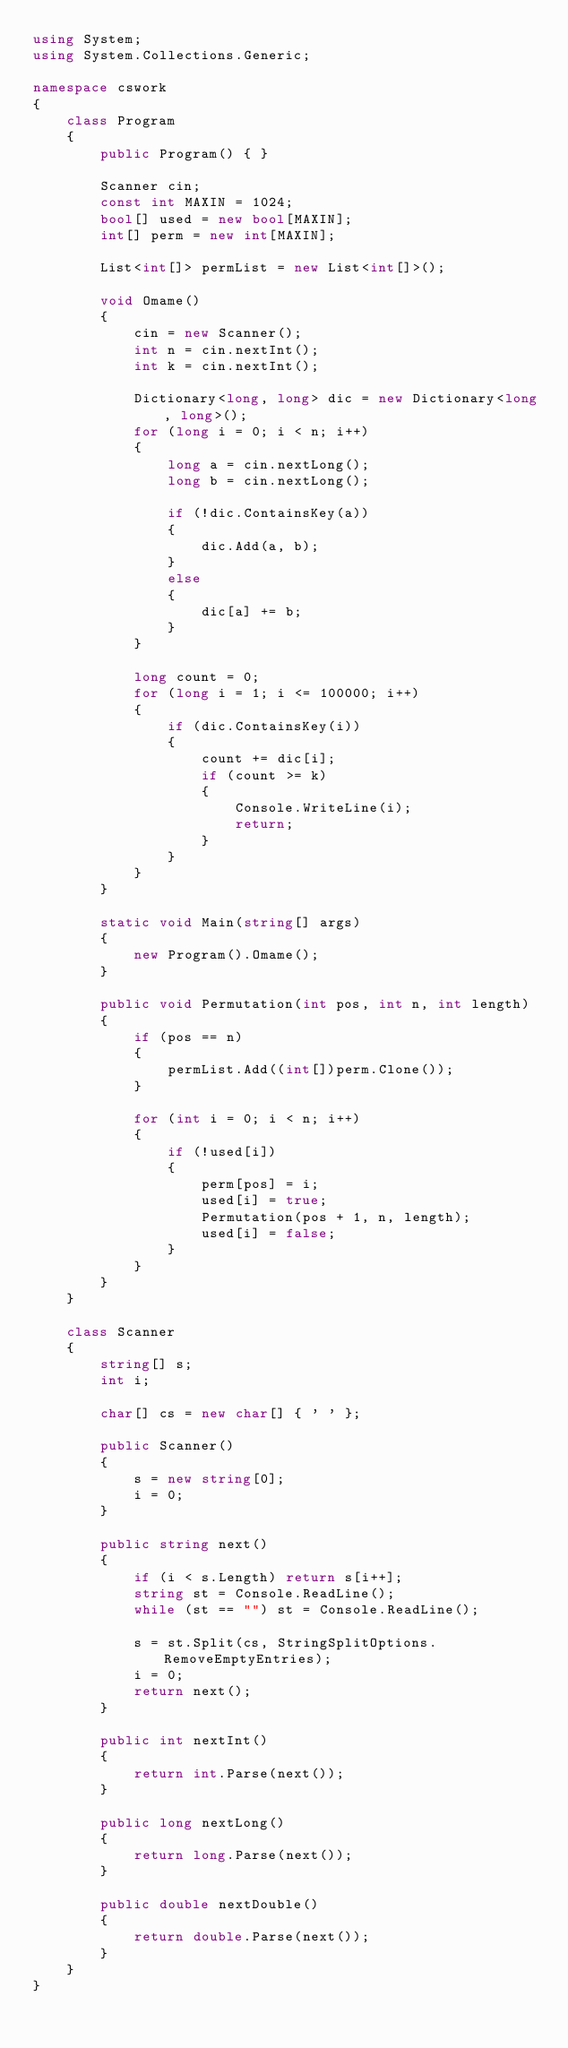<code> <loc_0><loc_0><loc_500><loc_500><_C#_>using System;
using System.Collections.Generic;

namespace cswork
{
    class Program
    {
        public Program() { }

        Scanner cin;
        const int MAXIN = 1024;
        bool[] used = new bool[MAXIN];
        int[] perm = new int[MAXIN];

        List<int[]> permList = new List<int[]>();

        void Omame()
        {
            cin = new Scanner();
            int n = cin.nextInt();
            int k = cin.nextInt();

            Dictionary<long, long> dic = new Dictionary<long, long>();
            for (long i = 0; i < n; i++)
            {
                long a = cin.nextLong();
                long b = cin.nextLong();

                if (!dic.ContainsKey(a))
                {
                    dic.Add(a, b);
                }
                else
                {
                    dic[a] += b;
                }
            }

            long count = 0;
            for (long i = 1; i <= 100000; i++)
            {
                if (dic.ContainsKey(i))
                {
                    count += dic[i];
                    if (count >= k)
                    {
                        Console.WriteLine(i);
                        return;
                    }
                }
            }
        }

        static void Main(string[] args)
        {
            new Program().Omame();
        }

        public void Permutation(int pos, int n, int length)
        {
            if (pos == n)
            {
                permList.Add((int[])perm.Clone());
            }

            for (int i = 0; i < n; i++)
            {
                if (!used[i])
                {
                    perm[pos] = i;
                    used[i] = true;
                    Permutation(pos + 1, n, length);
                    used[i] = false;
                }
            }
        }
    }

    class Scanner
    {
        string[] s;
        int i;

        char[] cs = new char[] { ' ' };

        public Scanner()
        {
            s = new string[0];
            i = 0;
        }

        public string next()
        {
            if (i < s.Length) return s[i++];
            string st = Console.ReadLine();
            while (st == "") st = Console.ReadLine();

            s = st.Split(cs, StringSplitOptions.RemoveEmptyEntries);
            i = 0;
            return next();
        }

        public int nextInt()
        {
            return int.Parse(next());
        }

        public long nextLong()
        {
            return long.Parse(next());
        }

        public double nextDouble()
        {
            return double.Parse(next());
        }
    }
}</code> 